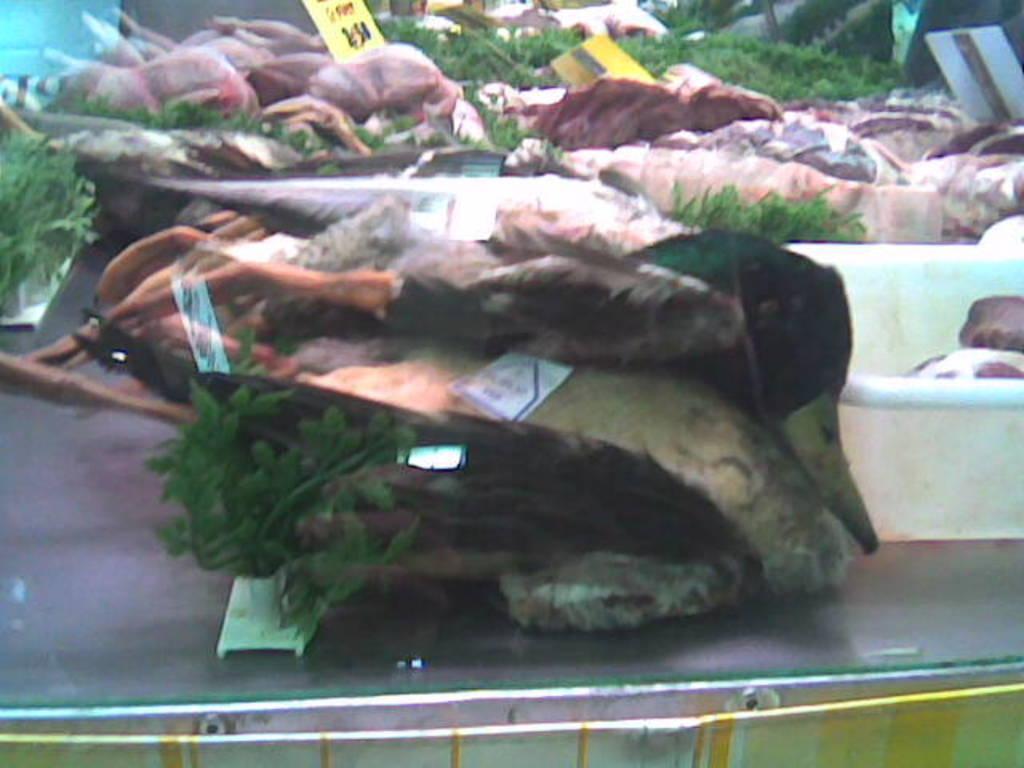Can you describe this image briefly? In this image there is meat with price tags. 